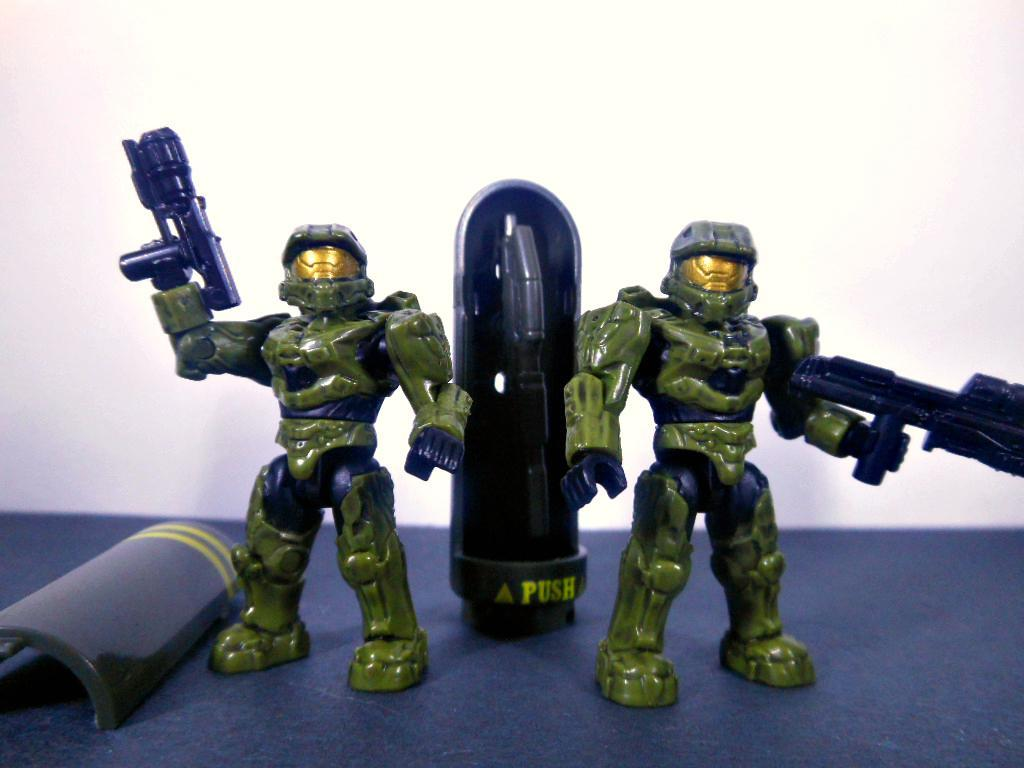How many toys are visible in the image? There are two toys in the image. What colors are the toys? The toys are in green and black color. What is the surface on which the toys are standing? The toys are standing on a black color surface. What color is the background of the image? The background of the image is white. What type of juice is being served in the image? There is no juice present in the image; it features two toys on a black surface with a white background. 